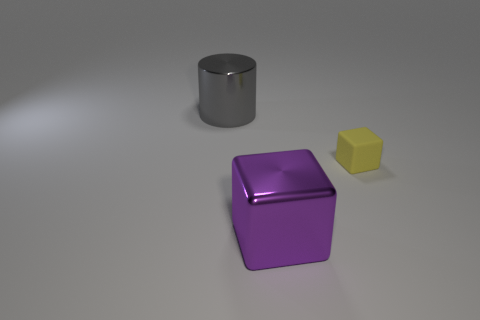Is there anything else that has the same size as the yellow rubber block?
Offer a terse response. No. There is a object that is on the left side of the small yellow matte block and behind the big cube; what color is it?
Give a very brief answer. Gray. What color is the cube that is behind the metallic object that is right of the large metal object behind the small yellow block?
Ensure brevity in your answer.  Yellow. There is a matte thing that is the same shape as the purple shiny thing; what is its color?
Give a very brief answer. Yellow. How many other objects are there of the same material as the big cylinder?
Keep it short and to the point. 1. What is the size of the yellow thing?
Give a very brief answer. Small. Are there any green objects that have the same shape as the purple metal object?
Your answer should be very brief. No. What number of things are gray matte cylinders or big things to the right of the metal cylinder?
Your answer should be very brief. 1. There is a metallic thing that is in front of the large metallic cylinder; what color is it?
Provide a succinct answer. Purple. Does the metallic thing in front of the yellow rubber cube have the same size as the metal thing behind the small yellow matte object?
Your response must be concise. Yes. 